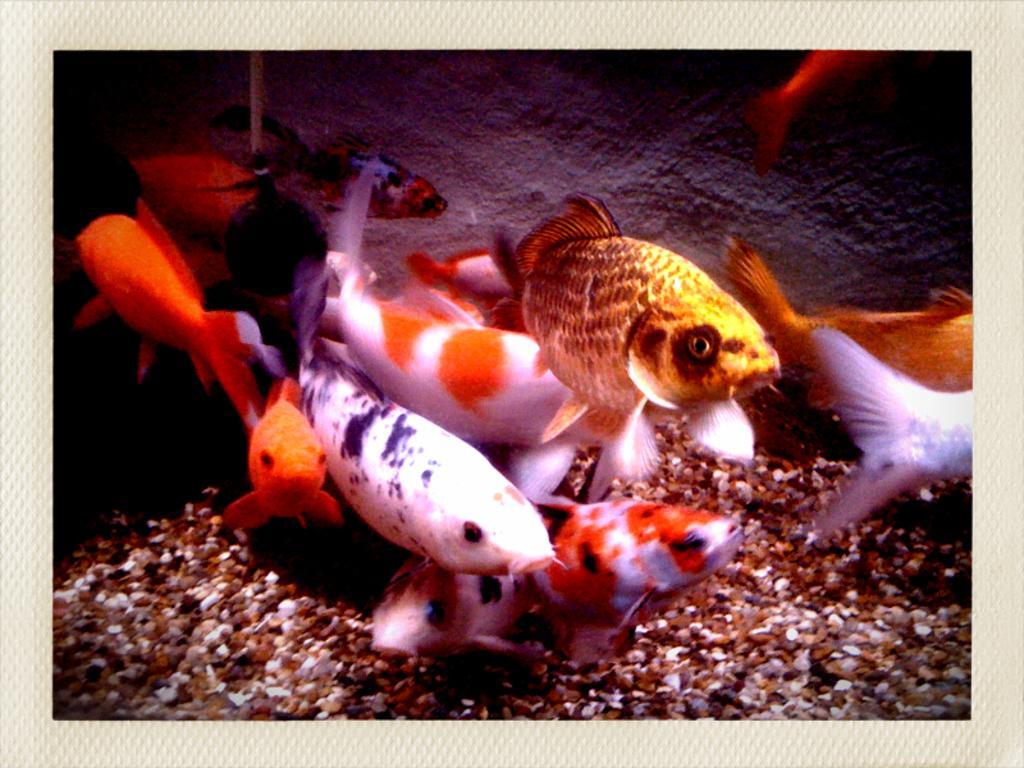Could you give a brief overview of what you see in this image? In this image, we can see few fishes, stones and wall. The border of the image, there is a white color. 